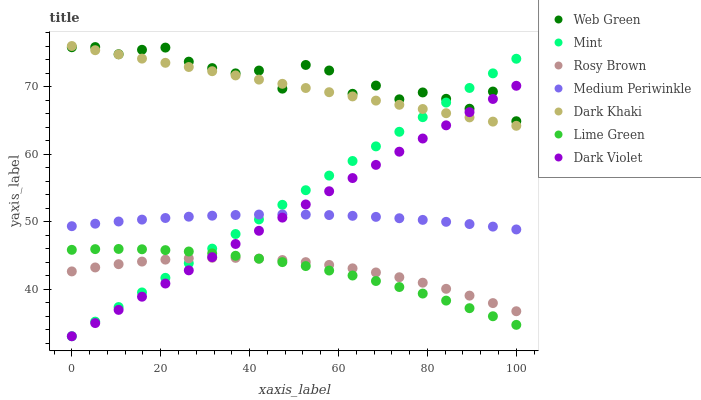Does Lime Green have the minimum area under the curve?
Answer yes or no. Yes. Does Web Green have the maximum area under the curve?
Answer yes or no. Yes. Does Rosy Brown have the minimum area under the curve?
Answer yes or no. No. Does Rosy Brown have the maximum area under the curve?
Answer yes or no. No. Is Mint the smoothest?
Answer yes or no. Yes. Is Web Green the roughest?
Answer yes or no. Yes. Is Rosy Brown the smoothest?
Answer yes or no. No. Is Rosy Brown the roughest?
Answer yes or no. No. Does Dark Violet have the lowest value?
Answer yes or no. Yes. Does Rosy Brown have the lowest value?
Answer yes or no. No. Does Dark Khaki have the highest value?
Answer yes or no. Yes. Does Medium Periwinkle have the highest value?
Answer yes or no. No. Is Medium Periwinkle less than Dark Khaki?
Answer yes or no. Yes. Is Medium Periwinkle greater than Rosy Brown?
Answer yes or no. Yes. Does Web Green intersect Dark Khaki?
Answer yes or no. Yes. Is Web Green less than Dark Khaki?
Answer yes or no. No. Is Web Green greater than Dark Khaki?
Answer yes or no. No. Does Medium Periwinkle intersect Dark Khaki?
Answer yes or no. No. 